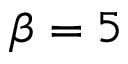Convert formula to latex. <formula><loc_0><loc_0><loc_500><loc_500>\beta = 5</formula> 